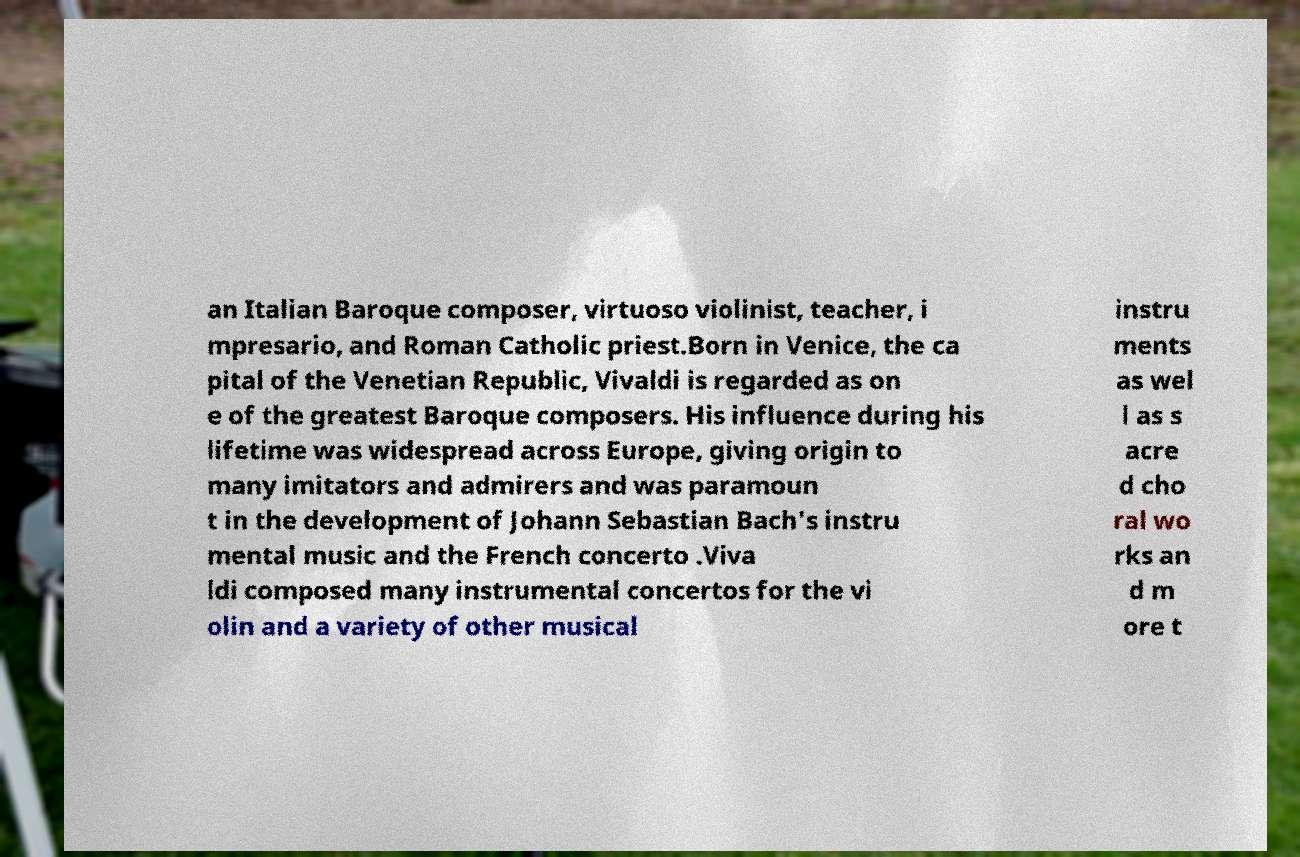Can you read and provide the text displayed in the image?This photo seems to have some interesting text. Can you extract and type it out for me? an Italian Baroque composer, virtuoso violinist, teacher, i mpresario, and Roman Catholic priest.Born in Venice, the ca pital of the Venetian Republic, Vivaldi is regarded as on e of the greatest Baroque composers. His influence during his lifetime was widespread across Europe, giving origin to many imitators and admirers and was paramoun t in the development of Johann Sebastian Bach's instru mental music and the French concerto .Viva ldi composed many instrumental concertos for the vi olin and a variety of other musical instru ments as wel l as s acre d cho ral wo rks an d m ore t 